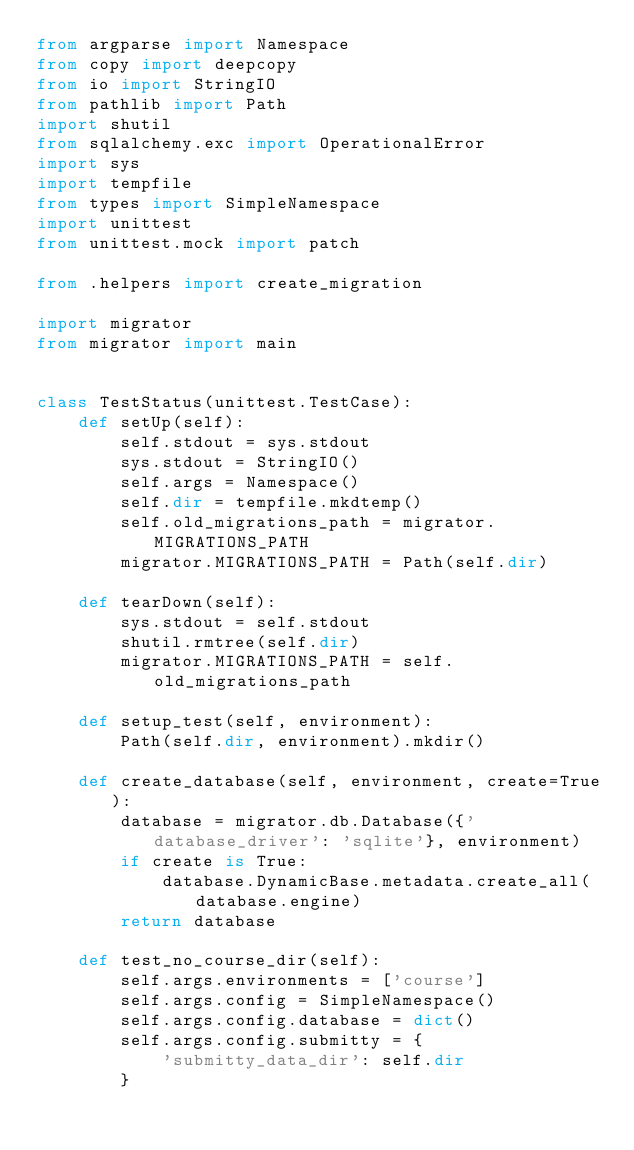Convert code to text. <code><loc_0><loc_0><loc_500><loc_500><_Python_>from argparse import Namespace
from copy import deepcopy
from io import StringIO
from pathlib import Path
import shutil
from sqlalchemy.exc import OperationalError
import sys
import tempfile
from types import SimpleNamespace
import unittest
from unittest.mock import patch

from .helpers import create_migration

import migrator
from migrator import main


class TestStatus(unittest.TestCase):
    def setUp(self):
        self.stdout = sys.stdout
        sys.stdout = StringIO()
        self.args = Namespace()
        self.dir = tempfile.mkdtemp()
        self.old_migrations_path = migrator.MIGRATIONS_PATH
        migrator.MIGRATIONS_PATH = Path(self.dir)

    def tearDown(self):
        sys.stdout = self.stdout
        shutil.rmtree(self.dir)
        migrator.MIGRATIONS_PATH = self.old_migrations_path

    def setup_test(self, environment):
        Path(self.dir, environment).mkdir()

    def create_database(self, environment, create=True):
        database = migrator.db.Database({'database_driver': 'sqlite'}, environment)
        if create is True:
            database.DynamicBase.metadata.create_all(database.engine)
        return database

    def test_no_course_dir(self):
        self.args.environments = ['course']
        self.args.config = SimpleNamespace()
        self.args.config.database = dict()
        self.args.config.submitty = {
            'submitty_data_dir': self.dir
        }</code> 